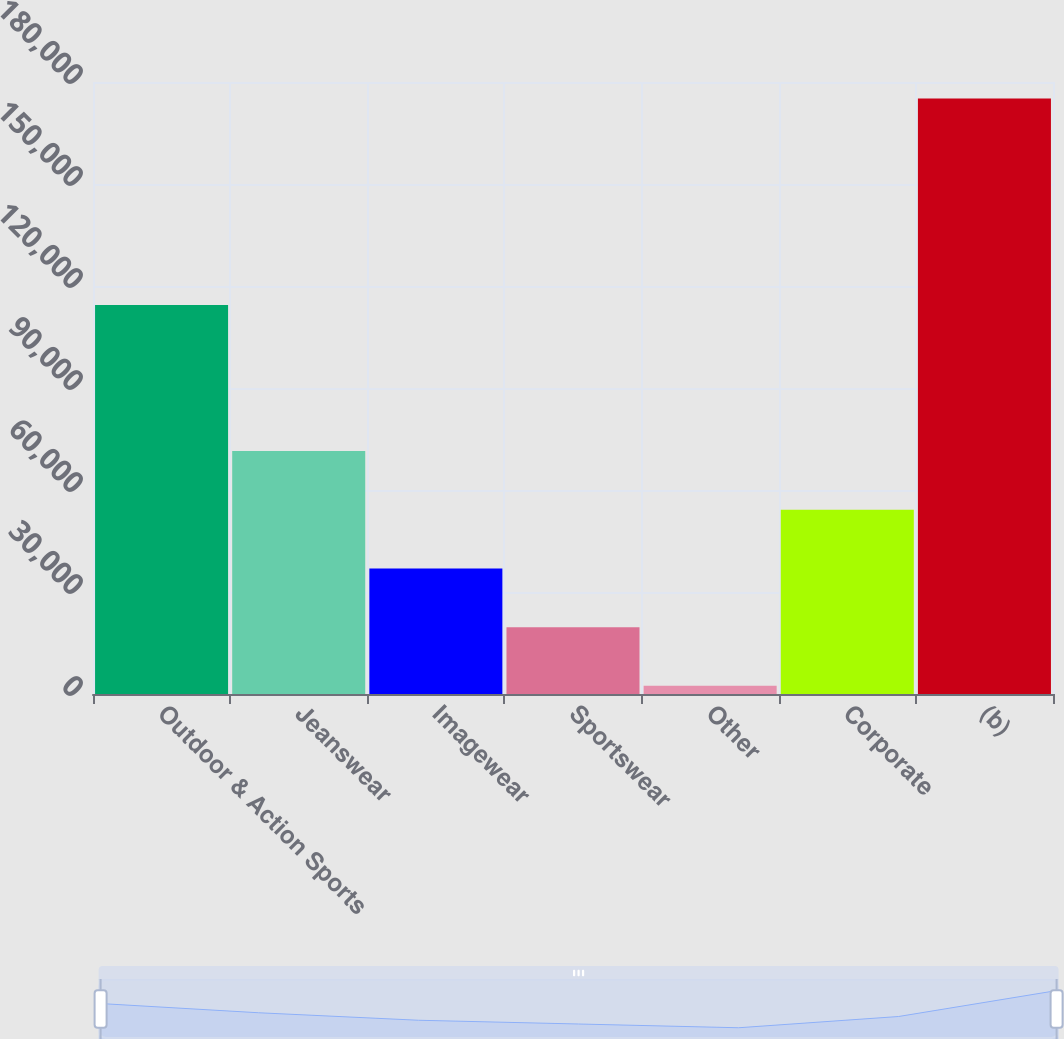Convert chart. <chart><loc_0><loc_0><loc_500><loc_500><bar_chart><fcel>Outdoor & Action Sports<fcel>Jeanswear<fcel>Imagewear<fcel>Sportswear<fcel>Other<fcel>Corporate<fcel>(b)<nl><fcel>114430<fcel>71482.4<fcel>36936.2<fcel>19663.1<fcel>2390<fcel>54209.3<fcel>175121<nl></chart> 